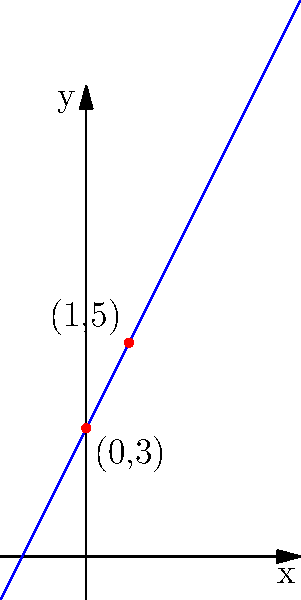Given the linear equation $y = 2x + 3$, graph the line on a coordinate system. Identify the y-intercept and calculate the slope using two points on the line. How does this method reinforce the fundamental concepts of linear equations? To graph the linear equation $y = 2x + 3$ and reinforce fundamental concepts:

1. Identify the y-intercept:
   - When $x = 0$, $y = 2(0) + 3 = 3$
   - The y-intercept is (0, 3)

2. Plot the y-intercept on the coordinate system.

3. Use the slope to find another point:
   - The slope is the coefficient of x, which is 2
   - From (0, 3), move right 1 unit and up 2 units
   - This gives the point (1, 5)

4. Plot the second point (1, 5) on the coordinate system.

5. Draw a straight line through these two points.

6. Verify the slope using the two points:
   - Slope = (y₂ - y₁) / (x₂ - x₁) = (5 - 3) / (1 - 0) = 2/1 = 2

This method reinforces:
- The y-intercept as the point where the line crosses the y-axis
- The slope as the rate of change between any two points on the line
- The slope-intercept form of a linear equation: $y = mx + b$, where m is the slope and b is the y-intercept
Answer: y-intercept: (0, 3); slope: 2 